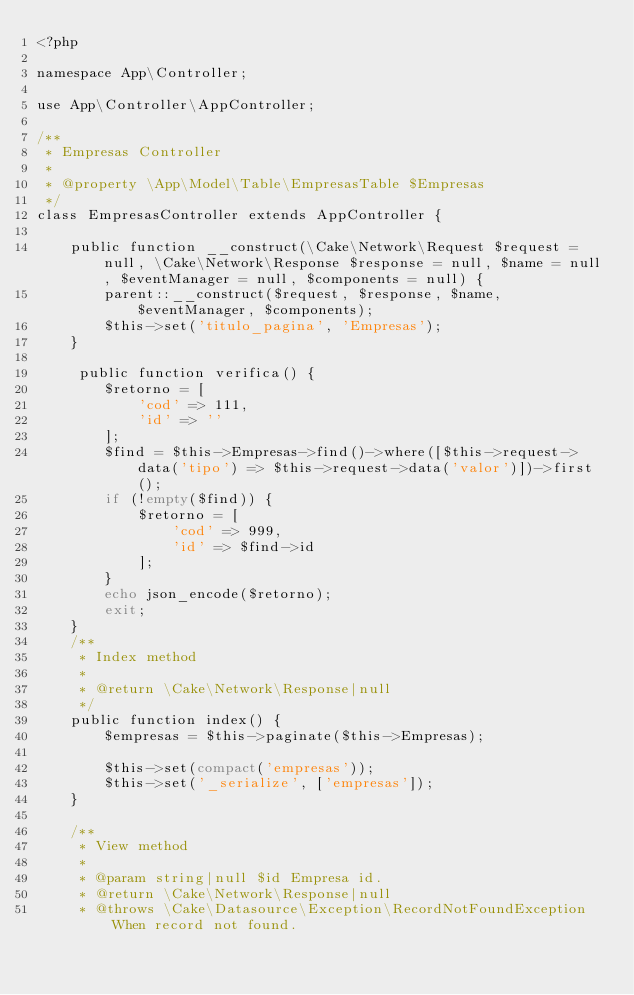Convert code to text. <code><loc_0><loc_0><loc_500><loc_500><_PHP_><?php

namespace App\Controller;

use App\Controller\AppController;

/**
 * Empresas Controller
 *
 * @property \App\Model\Table\EmpresasTable $Empresas
 */
class EmpresasController extends AppController {

    public function __construct(\Cake\Network\Request $request = null, \Cake\Network\Response $response = null, $name = null, $eventManager = null, $components = null) {
        parent::__construct($request, $response, $name, $eventManager, $components);
        $this->set('titulo_pagina', 'Empresas');
    }

     public function verifica() {
        $retorno = [
            'cod' => 111,
            'id' => ''
        ];
        $find = $this->Empresas->find()->where([$this->request->data('tipo') => $this->request->data('valor')])->first();
        if (!empty($find)) {
            $retorno = [
                'cod' => 999,
                'id' => $find->id
            ];
        }
        echo json_encode($retorno);
        exit;
    }
    /**
     * Index method
     *
     * @return \Cake\Network\Response|null
     */
    public function index() {
        $empresas = $this->paginate($this->Empresas);

        $this->set(compact('empresas'));
        $this->set('_serialize', ['empresas']);
    }

    /**
     * View method
     *
     * @param string|null $id Empresa id.
     * @return \Cake\Network\Response|null
     * @throws \Cake\Datasource\Exception\RecordNotFoundException When record not found.</code> 